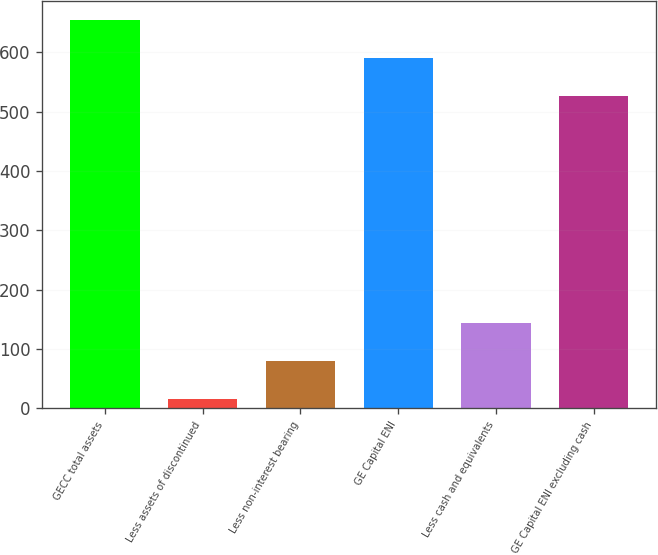<chart> <loc_0><loc_0><loc_500><loc_500><bar_chart><fcel>GECC total assets<fcel>Less assets of discontinued<fcel>Less non-interest bearing<fcel>GE Capital ENI<fcel>Less cash and equivalents<fcel>GE Capital ENI excluding cash<nl><fcel>654<fcel>15.1<fcel>78.95<fcel>590.15<fcel>142.8<fcel>526.3<nl></chart> 